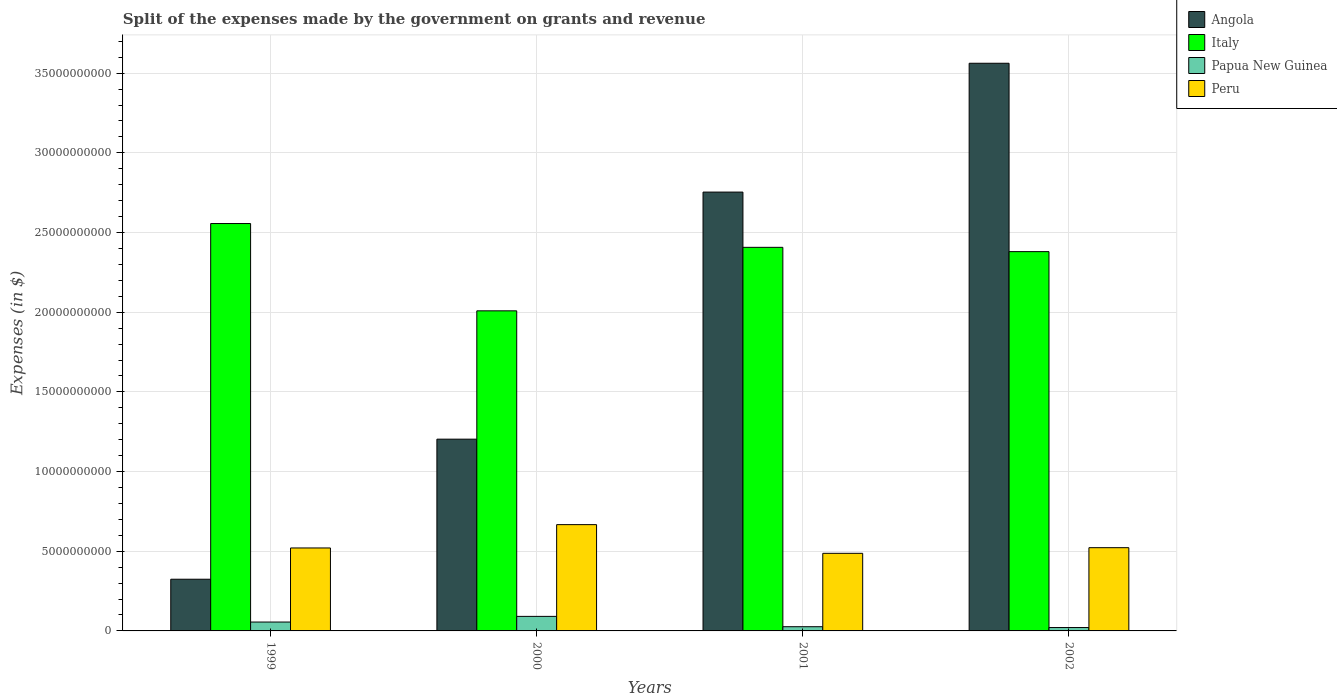How many different coloured bars are there?
Provide a short and direct response. 4. How many groups of bars are there?
Offer a very short reply. 4. What is the label of the 4th group of bars from the left?
Ensure brevity in your answer.  2002. What is the expenses made by the government on grants and revenue in Angola in 1999?
Your answer should be very brief. 3.24e+09. Across all years, what is the maximum expenses made by the government on grants and revenue in Angola?
Keep it short and to the point. 3.56e+1. Across all years, what is the minimum expenses made by the government on grants and revenue in Italy?
Your answer should be very brief. 2.01e+1. What is the total expenses made by the government on grants and revenue in Peru in the graph?
Your answer should be very brief. 2.20e+1. What is the difference between the expenses made by the government on grants and revenue in Angola in 1999 and that in 2002?
Provide a succinct answer. -3.24e+1. What is the difference between the expenses made by the government on grants and revenue in Angola in 2002 and the expenses made by the government on grants and revenue in Peru in 1999?
Make the answer very short. 3.04e+1. What is the average expenses made by the government on grants and revenue in Peru per year?
Provide a succinct answer. 5.49e+09. In the year 2002, what is the difference between the expenses made by the government on grants and revenue in Peru and expenses made by the government on grants and revenue in Angola?
Your answer should be very brief. -3.04e+1. What is the ratio of the expenses made by the government on grants and revenue in Peru in 1999 to that in 2000?
Provide a short and direct response. 0.78. Is the expenses made by the government on grants and revenue in Papua New Guinea in 2000 less than that in 2002?
Offer a very short reply. No. Is the difference between the expenses made by the government on grants and revenue in Peru in 1999 and 2001 greater than the difference between the expenses made by the government on grants and revenue in Angola in 1999 and 2001?
Offer a terse response. Yes. What is the difference between the highest and the second highest expenses made by the government on grants and revenue in Italy?
Make the answer very short. 1.49e+09. What is the difference between the highest and the lowest expenses made by the government on grants and revenue in Angola?
Your answer should be compact. 3.24e+1. In how many years, is the expenses made by the government on grants and revenue in Italy greater than the average expenses made by the government on grants and revenue in Italy taken over all years?
Your answer should be very brief. 3. Is it the case that in every year, the sum of the expenses made by the government on grants and revenue in Peru and expenses made by the government on grants and revenue in Italy is greater than the sum of expenses made by the government on grants and revenue in Angola and expenses made by the government on grants and revenue in Papua New Guinea?
Give a very brief answer. No. What does the 2nd bar from the left in 2001 represents?
Your answer should be very brief. Italy. What does the 1st bar from the right in 2000 represents?
Make the answer very short. Peru. How many bars are there?
Offer a very short reply. 16. Are all the bars in the graph horizontal?
Provide a succinct answer. No. How many years are there in the graph?
Provide a short and direct response. 4. Are the values on the major ticks of Y-axis written in scientific E-notation?
Your response must be concise. No. Where does the legend appear in the graph?
Offer a terse response. Top right. How many legend labels are there?
Offer a terse response. 4. How are the legend labels stacked?
Give a very brief answer. Vertical. What is the title of the graph?
Ensure brevity in your answer.  Split of the expenses made by the government on grants and revenue. What is the label or title of the Y-axis?
Give a very brief answer. Expenses (in $). What is the Expenses (in $) in Angola in 1999?
Give a very brief answer. 3.24e+09. What is the Expenses (in $) of Italy in 1999?
Give a very brief answer. 2.56e+1. What is the Expenses (in $) of Papua New Guinea in 1999?
Offer a very short reply. 5.58e+08. What is the Expenses (in $) of Peru in 1999?
Your answer should be compact. 5.21e+09. What is the Expenses (in $) of Angola in 2000?
Your response must be concise. 1.20e+1. What is the Expenses (in $) in Italy in 2000?
Give a very brief answer. 2.01e+1. What is the Expenses (in $) of Papua New Guinea in 2000?
Give a very brief answer. 9.12e+08. What is the Expenses (in $) of Peru in 2000?
Provide a short and direct response. 6.67e+09. What is the Expenses (in $) in Angola in 2001?
Give a very brief answer. 2.75e+1. What is the Expenses (in $) in Italy in 2001?
Ensure brevity in your answer.  2.41e+1. What is the Expenses (in $) of Papua New Guinea in 2001?
Your answer should be very brief. 2.64e+08. What is the Expenses (in $) of Peru in 2001?
Your answer should be compact. 4.87e+09. What is the Expenses (in $) of Angola in 2002?
Offer a very short reply. 3.56e+1. What is the Expenses (in $) in Italy in 2002?
Ensure brevity in your answer.  2.38e+1. What is the Expenses (in $) of Papua New Guinea in 2002?
Offer a very short reply. 2.13e+08. What is the Expenses (in $) of Peru in 2002?
Offer a terse response. 5.22e+09. Across all years, what is the maximum Expenses (in $) of Angola?
Keep it short and to the point. 3.56e+1. Across all years, what is the maximum Expenses (in $) of Italy?
Your response must be concise. 2.56e+1. Across all years, what is the maximum Expenses (in $) of Papua New Guinea?
Provide a succinct answer. 9.12e+08. Across all years, what is the maximum Expenses (in $) of Peru?
Ensure brevity in your answer.  6.67e+09. Across all years, what is the minimum Expenses (in $) of Angola?
Offer a very short reply. 3.24e+09. Across all years, what is the minimum Expenses (in $) in Italy?
Give a very brief answer. 2.01e+1. Across all years, what is the minimum Expenses (in $) in Papua New Guinea?
Provide a succinct answer. 2.13e+08. Across all years, what is the minimum Expenses (in $) in Peru?
Your answer should be very brief. 4.87e+09. What is the total Expenses (in $) of Angola in the graph?
Keep it short and to the point. 7.84e+1. What is the total Expenses (in $) in Italy in the graph?
Provide a succinct answer. 9.35e+1. What is the total Expenses (in $) in Papua New Guinea in the graph?
Provide a succinct answer. 1.95e+09. What is the total Expenses (in $) in Peru in the graph?
Make the answer very short. 2.20e+1. What is the difference between the Expenses (in $) in Angola in 1999 and that in 2000?
Offer a very short reply. -8.79e+09. What is the difference between the Expenses (in $) in Italy in 1999 and that in 2000?
Offer a very short reply. 5.48e+09. What is the difference between the Expenses (in $) in Papua New Guinea in 1999 and that in 2000?
Your answer should be very brief. -3.54e+08. What is the difference between the Expenses (in $) of Peru in 1999 and that in 2000?
Offer a terse response. -1.46e+09. What is the difference between the Expenses (in $) in Angola in 1999 and that in 2001?
Offer a terse response. -2.43e+1. What is the difference between the Expenses (in $) in Italy in 1999 and that in 2001?
Your response must be concise. 1.49e+09. What is the difference between the Expenses (in $) of Papua New Guinea in 1999 and that in 2001?
Your answer should be compact. 2.94e+08. What is the difference between the Expenses (in $) of Peru in 1999 and that in 2001?
Provide a short and direct response. 3.36e+08. What is the difference between the Expenses (in $) in Angola in 1999 and that in 2002?
Your response must be concise. -3.24e+1. What is the difference between the Expenses (in $) of Italy in 1999 and that in 2002?
Offer a very short reply. 1.76e+09. What is the difference between the Expenses (in $) in Papua New Guinea in 1999 and that in 2002?
Your response must be concise. 3.45e+08. What is the difference between the Expenses (in $) of Peru in 1999 and that in 2002?
Offer a terse response. -1.78e+07. What is the difference between the Expenses (in $) of Angola in 2000 and that in 2001?
Ensure brevity in your answer.  -1.55e+1. What is the difference between the Expenses (in $) of Italy in 2000 and that in 2001?
Ensure brevity in your answer.  -3.98e+09. What is the difference between the Expenses (in $) of Papua New Guinea in 2000 and that in 2001?
Offer a very short reply. 6.48e+08. What is the difference between the Expenses (in $) of Peru in 2000 and that in 2001?
Your answer should be very brief. 1.80e+09. What is the difference between the Expenses (in $) of Angola in 2000 and that in 2002?
Make the answer very short. -2.36e+1. What is the difference between the Expenses (in $) of Italy in 2000 and that in 2002?
Ensure brevity in your answer.  -3.72e+09. What is the difference between the Expenses (in $) in Papua New Guinea in 2000 and that in 2002?
Offer a very short reply. 6.99e+08. What is the difference between the Expenses (in $) of Peru in 2000 and that in 2002?
Ensure brevity in your answer.  1.45e+09. What is the difference between the Expenses (in $) of Angola in 2001 and that in 2002?
Give a very brief answer. -8.08e+09. What is the difference between the Expenses (in $) of Italy in 2001 and that in 2002?
Your answer should be very brief. 2.69e+08. What is the difference between the Expenses (in $) of Papua New Guinea in 2001 and that in 2002?
Offer a terse response. 5.13e+07. What is the difference between the Expenses (in $) of Peru in 2001 and that in 2002?
Make the answer very short. -3.54e+08. What is the difference between the Expenses (in $) of Angola in 1999 and the Expenses (in $) of Italy in 2000?
Ensure brevity in your answer.  -1.68e+1. What is the difference between the Expenses (in $) of Angola in 1999 and the Expenses (in $) of Papua New Guinea in 2000?
Your answer should be compact. 2.33e+09. What is the difference between the Expenses (in $) in Angola in 1999 and the Expenses (in $) in Peru in 2000?
Provide a succinct answer. -3.43e+09. What is the difference between the Expenses (in $) of Italy in 1999 and the Expenses (in $) of Papua New Guinea in 2000?
Ensure brevity in your answer.  2.47e+1. What is the difference between the Expenses (in $) of Italy in 1999 and the Expenses (in $) of Peru in 2000?
Your answer should be compact. 1.89e+1. What is the difference between the Expenses (in $) of Papua New Guinea in 1999 and the Expenses (in $) of Peru in 2000?
Offer a terse response. -6.11e+09. What is the difference between the Expenses (in $) in Angola in 1999 and the Expenses (in $) in Italy in 2001?
Give a very brief answer. -2.08e+1. What is the difference between the Expenses (in $) in Angola in 1999 and the Expenses (in $) in Papua New Guinea in 2001?
Give a very brief answer. 2.98e+09. What is the difference between the Expenses (in $) in Angola in 1999 and the Expenses (in $) in Peru in 2001?
Your response must be concise. -1.63e+09. What is the difference between the Expenses (in $) of Italy in 1999 and the Expenses (in $) of Papua New Guinea in 2001?
Offer a terse response. 2.53e+1. What is the difference between the Expenses (in $) in Italy in 1999 and the Expenses (in $) in Peru in 2001?
Provide a succinct answer. 2.07e+1. What is the difference between the Expenses (in $) in Papua New Guinea in 1999 and the Expenses (in $) in Peru in 2001?
Your answer should be compact. -4.31e+09. What is the difference between the Expenses (in $) of Angola in 1999 and the Expenses (in $) of Italy in 2002?
Your answer should be very brief. -2.06e+1. What is the difference between the Expenses (in $) in Angola in 1999 and the Expenses (in $) in Papua New Guinea in 2002?
Provide a succinct answer. 3.03e+09. What is the difference between the Expenses (in $) of Angola in 1999 and the Expenses (in $) of Peru in 2002?
Offer a terse response. -1.98e+09. What is the difference between the Expenses (in $) in Italy in 1999 and the Expenses (in $) in Papua New Guinea in 2002?
Make the answer very short. 2.54e+1. What is the difference between the Expenses (in $) in Italy in 1999 and the Expenses (in $) in Peru in 2002?
Ensure brevity in your answer.  2.03e+1. What is the difference between the Expenses (in $) in Papua New Guinea in 1999 and the Expenses (in $) in Peru in 2002?
Your response must be concise. -4.67e+09. What is the difference between the Expenses (in $) in Angola in 2000 and the Expenses (in $) in Italy in 2001?
Your answer should be compact. -1.20e+1. What is the difference between the Expenses (in $) of Angola in 2000 and the Expenses (in $) of Papua New Guinea in 2001?
Make the answer very short. 1.18e+1. What is the difference between the Expenses (in $) in Angola in 2000 and the Expenses (in $) in Peru in 2001?
Keep it short and to the point. 7.16e+09. What is the difference between the Expenses (in $) in Italy in 2000 and the Expenses (in $) in Papua New Guinea in 2001?
Your answer should be compact. 1.98e+1. What is the difference between the Expenses (in $) of Italy in 2000 and the Expenses (in $) of Peru in 2001?
Your answer should be compact. 1.52e+1. What is the difference between the Expenses (in $) of Papua New Guinea in 2000 and the Expenses (in $) of Peru in 2001?
Offer a terse response. -3.96e+09. What is the difference between the Expenses (in $) in Angola in 2000 and the Expenses (in $) in Italy in 2002?
Ensure brevity in your answer.  -1.18e+1. What is the difference between the Expenses (in $) of Angola in 2000 and the Expenses (in $) of Papua New Guinea in 2002?
Ensure brevity in your answer.  1.18e+1. What is the difference between the Expenses (in $) in Angola in 2000 and the Expenses (in $) in Peru in 2002?
Your answer should be compact. 6.81e+09. What is the difference between the Expenses (in $) in Italy in 2000 and the Expenses (in $) in Papua New Guinea in 2002?
Your answer should be compact. 1.99e+1. What is the difference between the Expenses (in $) in Italy in 2000 and the Expenses (in $) in Peru in 2002?
Make the answer very short. 1.49e+1. What is the difference between the Expenses (in $) of Papua New Guinea in 2000 and the Expenses (in $) of Peru in 2002?
Give a very brief answer. -4.31e+09. What is the difference between the Expenses (in $) in Angola in 2001 and the Expenses (in $) in Italy in 2002?
Your response must be concise. 3.74e+09. What is the difference between the Expenses (in $) in Angola in 2001 and the Expenses (in $) in Papua New Guinea in 2002?
Offer a very short reply. 2.73e+1. What is the difference between the Expenses (in $) in Angola in 2001 and the Expenses (in $) in Peru in 2002?
Ensure brevity in your answer.  2.23e+1. What is the difference between the Expenses (in $) of Italy in 2001 and the Expenses (in $) of Papua New Guinea in 2002?
Give a very brief answer. 2.39e+1. What is the difference between the Expenses (in $) in Italy in 2001 and the Expenses (in $) in Peru in 2002?
Your response must be concise. 1.88e+1. What is the difference between the Expenses (in $) in Papua New Guinea in 2001 and the Expenses (in $) in Peru in 2002?
Ensure brevity in your answer.  -4.96e+09. What is the average Expenses (in $) of Angola per year?
Make the answer very short. 1.96e+1. What is the average Expenses (in $) in Italy per year?
Give a very brief answer. 2.34e+1. What is the average Expenses (in $) of Papua New Guinea per year?
Ensure brevity in your answer.  4.86e+08. What is the average Expenses (in $) of Peru per year?
Give a very brief answer. 5.49e+09. In the year 1999, what is the difference between the Expenses (in $) in Angola and Expenses (in $) in Italy?
Give a very brief answer. -2.23e+1. In the year 1999, what is the difference between the Expenses (in $) of Angola and Expenses (in $) of Papua New Guinea?
Provide a short and direct response. 2.69e+09. In the year 1999, what is the difference between the Expenses (in $) of Angola and Expenses (in $) of Peru?
Provide a short and direct response. -1.96e+09. In the year 1999, what is the difference between the Expenses (in $) of Italy and Expenses (in $) of Papua New Guinea?
Your answer should be very brief. 2.50e+1. In the year 1999, what is the difference between the Expenses (in $) in Italy and Expenses (in $) in Peru?
Ensure brevity in your answer.  2.04e+1. In the year 1999, what is the difference between the Expenses (in $) in Papua New Guinea and Expenses (in $) in Peru?
Offer a terse response. -4.65e+09. In the year 2000, what is the difference between the Expenses (in $) of Angola and Expenses (in $) of Italy?
Keep it short and to the point. -8.05e+09. In the year 2000, what is the difference between the Expenses (in $) of Angola and Expenses (in $) of Papua New Guinea?
Offer a terse response. 1.11e+1. In the year 2000, what is the difference between the Expenses (in $) in Angola and Expenses (in $) in Peru?
Give a very brief answer. 5.36e+09. In the year 2000, what is the difference between the Expenses (in $) in Italy and Expenses (in $) in Papua New Guinea?
Your answer should be compact. 1.92e+1. In the year 2000, what is the difference between the Expenses (in $) of Italy and Expenses (in $) of Peru?
Make the answer very short. 1.34e+1. In the year 2000, what is the difference between the Expenses (in $) of Papua New Guinea and Expenses (in $) of Peru?
Provide a short and direct response. -5.76e+09. In the year 2001, what is the difference between the Expenses (in $) of Angola and Expenses (in $) of Italy?
Your answer should be compact. 3.47e+09. In the year 2001, what is the difference between the Expenses (in $) of Angola and Expenses (in $) of Papua New Guinea?
Provide a short and direct response. 2.73e+1. In the year 2001, what is the difference between the Expenses (in $) in Angola and Expenses (in $) in Peru?
Your answer should be very brief. 2.27e+1. In the year 2001, what is the difference between the Expenses (in $) of Italy and Expenses (in $) of Papua New Guinea?
Offer a terse response. 2.38e+1. In the year 2001, what is the difference between the Expenses (in $) in Italy and Expenses (in $) in Peru?
Offer a very short reply. 1.92e+1. In the year 2001, what is the difference between the Expenses (in $) of Papua New Guinea and Expenses (in $) of Peru?
Offer a very short reply. -4.61e+09. In the year 2002, what is the difference between the Expenses (in $) of Angola and Expenses (in $) of Italy?
Offer a terse response. 1.18e+1. In the year 2002, what is the difference between the Expenses (in $) in Angola and Expenses (in $) in Papua New Guinea?
Provide a short and direct response. 3.54e+1. In the year 2002, what is the difference between the Expenses (in $) of Angola and Expenses (in $) of Peru?
Provide a succinct answer. 3.04e+1. In the year 2002, what is the difference between the Expenses (in $) in Italy and Expenses (in $) in Papua New Guinea?
Offer a terse response. 2.36e+1. In the year 2002, what is the difference between the Expenses (in $) of Italy and Expenses (in $) of Peru?
Provide a short and direct response. 1.86e+1. In the year 2002, what is the difference between the Expenses (in $) in Papua New Guinea and Expenses (in $) in Peru?
Make the answer very short. -5.01e+09. What is the ratio of the Expenses (in $) in Angola in 1999 to that in 2000?
Your answer should be compact. 0.27. What is the ratio of the Expenses (in $) of Italy in 1999 to that in 2000?
Your answer should be very brief. 1.27. What is the ratio of the Expenses (in $) in Papua New Guinea in 1999 to that in 2000?
Offer a terse response. 0.61. What is the ratio of the Expenses (in $) in Peru in 1999 to that in 2000?
Keep it short and to the point. 0.78. What is the ratio of the Expenses (in $) of Angola in 1999 to that in 2001?
Offer a terse response. 0.12. What is the ratio of the Expenses (in $) in Italy in 1999 to that in 2001?
Provide a succinct answer. 1.06. What is the ratio of the Expenses (in $) of Papua New Guinea in 1999 to that in 2001?
Offer a very short reply. 2.11. What is the ratio of the Expenses (in $) of Peru in 1999 to that in 2001?
Give a very brief answer. 1.07. What is the ratio of the Expenses (in $) of Angola in 1999 to that in 2002?
Keep it short and to the point. 0.09. What is the ratio of the Expenses (in $) of Italy in 1999 to that in 2002?
Give a very brief answer. 1.07. What is the ratio of the Expenses (in $) of Papua New Guinea in 1999 to that in 2002?
Offer a terse response. 2.62. What is the ratio of the Expenses (in $) in Angola in 2000 to that in 2001?
Ensure brevity in your answer.  0.44. What is the ratio of the Expenses (in $) of Italy in 2000 to that in 2001?
Your response must be concise. 0.83. What is the ratio of the Expenses (in $) of Papua New Guinea in 2000 to that in 2001?
Your response must be concise. 3.46. What is the ratio of the Expenses (in $) in Peru in 2000 to that in 2001?
Offer a very short reply. 1.37. What is the ratio of the Expenses (in $) in Angola in 2000 to that in 2002?
Provide a short and direct response. 0.34. What is the ratio of the Expenses (in $) of Italy in 2000 to that in 2002?
Provide a succinct answer. 0.84. What is the ratio of the Expenses (in $) in Papua New Guinea in 2000 to that in 2002?
Your answer should be very brief. 4.29. What is the ratio of the Expenses (in $) in Peru in 2000 to that in 2002?
Offer a very short reply. 1.28. What is the ratio of the Expenses (in $) of Angola in 2001 to that in 2002?
Your answer should be compact. 0.77. What is the ratio of the Expenses (in $) of Italy in 2001 to that in 2002?
Keep it short and to the point. 1.01. What is the ratio of the Expenses (in $) in Papua New Guinea in 2001 to that in 2002?
Make the answer very short. 1.24. What is the ratio of the Expenses (in $) of Peru in 2001 to that in 2002?
Keep it short and to the point. 0.93. What is the difference between the highest and the second highest Expenses (in $) in Angola?
Offer a very short reply. 8.08e+09. What is the difference between the highest and the second highest Expenses (in $) of Italy?
Provide a succinct answer. 1.49e+09. What is the difference between the highest and the second highest Expenses (in $) in Papua New Guinea?
Keep it short and to the point. 3.54e+08. What is the difference between the highest and the second highest Expenses (in $) of Peru?
Your answer should be very brief. 1.45e+09. What is the difference between the highest and the lowest Expenses (in $) of Angola?
Provide a succinct answer. 3.24e+1. What is the difference between the highest and the lowest Expenses (in $) of Italy?
Your answer should be compact. 5.48e+09. What is the difference between the highest and the lowest Expenses (in $) in Papua New Guinea?
Make the answer very short. 6.99e+08. What is the difference between the highest and the lowest Expenses (in $) in Peru?
Offer a terse response. 1.80e+09. 